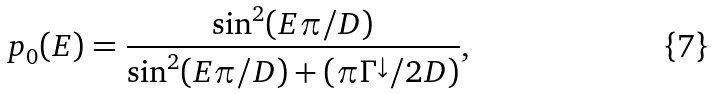<formula> <loc_0><loc_0><loc_500><loc_500>p _ { 0 } ( E ) = \frac { \sin ^ { 2 } ( E \pi / D ) } { \sin ^ { 2 } ( E \pi / D ) + ( \pi \Gamma ^ { \downarrow } / 2 D ) } ,</formula> 